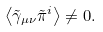<formula> <loc_0><loc_0><loc_500><loc_500>\left < \tilde { \gamma } _ { \mu \nu } \tilde { \pi } ^ { i } \right > \neq 0 .</formula> 